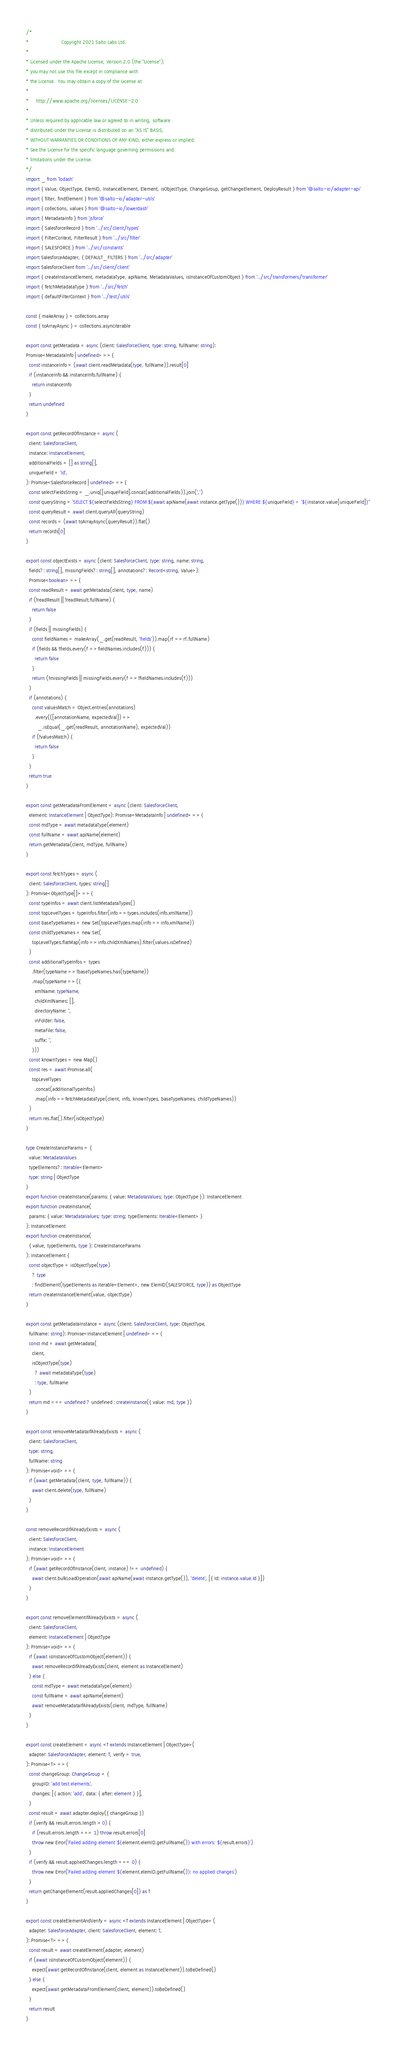Convert code to text. <code><loc_0><loc_0><loc_500><loc_500><_TypeScript_>/*
*                      Copyright 2021 Salto Labs Ltd.
*
* Licensed under the Apache License, Version 2.0 (the "License");
* you may not use this file except in compliance with
* the License.  You may obtain a copy of the License at
*
*     http://www.apache.org/licenses/LICENSE-2.0
*
* Unless required by applicable law or agreed to in writing, software
* distributed under the License is distributed on an "AS IS" BASIS,
* WITHOUT WARRANTIES OR CONDITIONS OF ANY KIND, either express or implied.
* See the License for the specific language governing permissions and
* limitations under the License.
*/
import _ from 'lodash'
import { Value, ObjectType, ElemID, InstanceElement, Element, isObjectType, ChangeGroup, getChangeElement, DeployResult } from '@salto-io/adapter-api'
import { filter, findElement } from '@salto-io/adapter-utils'
import { collections, values } from '@salto-io/lowerdash'
import { MetadataInfo } from 'jsforce'
import { SalesforceRecord } from '../src/client/types'
import { FilterContext, FilterResult } from '../src/filter'
import { SALESFORCE } from '../src/constants'
import SalesforceAdapter, { DEFAULT_FILTERS } from '../src/adapter'
import SalesforceClient from '../src/client/client'
import { createInstanceElement, metadataType, apiName, MetadataValues, isInstanceOfCustomObject } from '../src/transformers/transformer'
import { fetchMetadataType } from '../src/fetch'
import { defaultFilterContext } from '../test/utils'

const { makeArray } = collections.array
const { toArrayAsync } = collections.asynciterable

export const getMetadata = async (client: SalesforceClient, type: string, fullName: string):
Promise<MetadataInfo | undefined> => {
  const instanceInfo = (await client.readMetadata(type, fullName)).result[0]
  if (instanceInfo && instanceInfo.fullName) {
    return instanceInfo
  }
  return undefined
}

export const getRecordOfInstance = async (
  client: SalesforceClient,
  instance: InstanceElement,
  additionalFields = [] as string[],
  uniqueField = 'Id',
): Promise<SalesforceRecord | undefined> => {
  const selectFieldsString = _.uniq([uniqueField].concat(additionalFields)).join(',')
  const queryString = `SELECT ${selectFieldsString} FROM ${await apiName(await instance.getType())} WHERE ${uniqueField} = '${instance.value[uniqueField]}'`
  const queryResult = await client.queryAll(queryString)
  const records = (await toArrayAsync(queryResult)).flat()
  return records[0]
}

export const objectExists = async (client: SalesforceClient, type: string, name: string,
  fields?: string[], missingFields?: string[], annotations?: Record<string, Value>):
  Promise<boolean> => {
  const readResult = await getMetadata(client, type, name)
  if (!readResult || !readResult.fullName) {
    return false
  }
  if (fields || missingFields) {
    const fieldNames = makeArray(_.get(readResult, 'fields')).map(rf => rf.fullName)
    if (fields && !fields.every(f => fieldNames.includes(f))) {
      return false
    }
    return (!missingFields || missingFields.every(f => !fieldNames.includes(f)))
  }
  if (annotations) {
    const valuesMatch = Object.entries(annotations)
      .every(([annotationName, expectedVal]) =>
        _.isEqual(_.get(readResult, annotationName), expectedVal))
    if (!valuesMatch) {
      return false
    }
  }
  return true
}

export const getMetadataFromElement = async (client: SalesforceClient,
  element: InstanceElement | ObjectType): Promise<MetadataInfo | undefined> => {
  const mdType = await metadataType(element)
  const fullName = await apiName(element)
  return getMetadata(client, mdType, fullName)
}

export const fetchTypes = async (
  client: SalesforceClient, types: string[]
): Promise<ObjectType[]> => {
  const typeInfos = await client.listMetadataTypes()
  const topLevelTypes = typeInfos.filter(info => types.includes(info.xmlName))
  const baseTypeNames = new Set(topLevelTypes.map(info => info.xmlName))
  const childTypeNames = new Set(
    topLevelTypes.flatMap(info => info.childXmlNames).filter(values.isDefined)
  )
  const additionalTypeInfos = types
    .filter(typeName => !baseTypeNames.has(typeName))
    .map(typeName => ({
      xmlName: typeName,
      childXmlNames: [],
      directoryName: '',
      inFolder: false,
      metaFile: false,
      suffix: '',
    }))
  const knownTypes = new Map()
  const res = await Promise.all(
    topLevelTypes
      .concat(additionalTypeInfos)
      .map(info => fetchMetadataType(client, info, knownTypes, baseTypeNames, childTypeNames))
  )
  return res.flat().filter(isObjectType)
}

type CreateInstanceParams = {
  value: MetadataValues
  typeElements?: Iterable<Element>
  type: string | ObjectType
}
export function createInstance(params: { value: MetadataValues; type: ObjectType }): InstanceElement
export function createInstance(
  params: { value: MetadataValues; type: string; typeElements: Iterable<Element> }
): InstanceElement
export function createInstance(
  { value, typeElements, type }: CreateInstanceParams
): InstanceElement {
  const objectType = isObjectType(type)
    ? type
    : findElement(typeElements as Iterable<Element>, new ElemID(SALESFORCE, type)) as ObjectType
  return createInstanceElement(value, objectType)
}

export const getMetadataInstance = async (client: SalesforceClient, type: ObjectType,
  fullName: string): Promise<InstanceElement | undefined> => {
  const md = await getMetadata(
    client,
    isObjectType(type)
      ? await metadataType(type)
      : type, fullName
  )
  return md === undefined ? undefined : createInstance({ value: md, type })
}

export const removeMetadataIfAlreadyExists = async (
  client: SalesforceClient,
  type: string,
  fullName: string
): Promise<void> => {
  if (await getMetadata(client, type, fullName)) {
    await client.delete(type, fullName)
  }
}

const removeRecordIfAlreadyExists = async (
  client: SalesforceClient,
  instance: InstanceElement
): Promise<void> => {
  if (await getRecordOfInstance(client, instance) !== undefined) {
    await client.bulkLoadOperation(await apiName(await instance.getType()), 'delete', [{ Id: instance.value.Id }])
  }
}

export const removeElementIfAlreadyExists = async (
  client: SalesforceClient,
  element: InstanceElement | ObjectType
): Promise<void> => {
  if (await isInstanceOfCustomObject(element)) {
    await removeRecordIfAlreadyExists(client, element as InstanceElement)
  } else {
    const mdType = await metadataType(element)
    const fullName = await apiName(element)
    await removeMetadataIfAlreadyExists(client, mdType, fullName)
  }
}

export const createElement = async <T extends InstanceElement | ObjectType>(
  adapter: SalesforceAdapter, element: T, verify = true,
): Promise<T> => {
  const changeGroup: ChangeGroup = {
    groupID: 'add test elements',
    changes: [{ action: 'add', data: { after: element } }],
  }
  const result = await adapter.deploy({ changeGroup })
  if (verify && result.errors.length > 0) {
    if (result.errors.length === 1) throw result.errors[0]
    throw new Error(`Failed adding element ${element.elemID.getFullName()} with errors: ${result.errors}`)
  }
  if (verify && result.appliedChanges.length === 0) {
    throw new Error(`Failed adding element ${element.elemID.getFullName()}: no applied changes`)
  }
  return getChangeElement(result.appliedChanges[0]) as T
}

export const createElementAndVerify = async <T extends InstanceElement | ObjectType> (
  adapter: SalesforceAdapter, client: SalesforceClient, element: T,
): Promise<T> => {
  const result = await createElement(adapter, element)
  if (await isInstanceOfCustomObject(element)) {
    expect(await getRecordOfInstance(client, element as InstanceElement)).toBeDefined()
  } else {
    expect(await getMetadataFromElement(client, element)).toBeDefined()
  }
  return result
}
</code> 